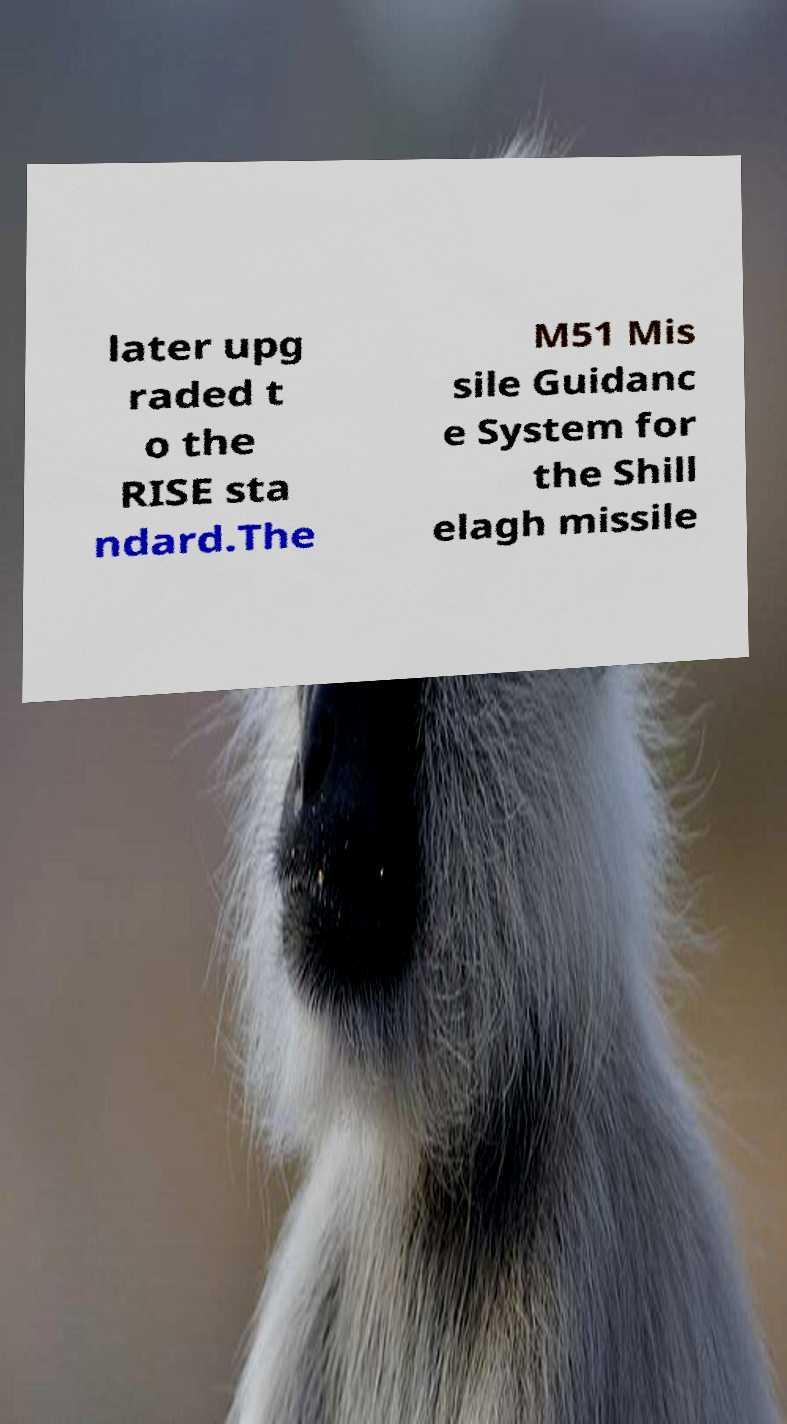Could you assist in decoding the text presented in this image and type it out clearly? later upg raded t o the RISE sta ndard.The M51 Mis sile Guidanc e System for the Shill elagh missile 